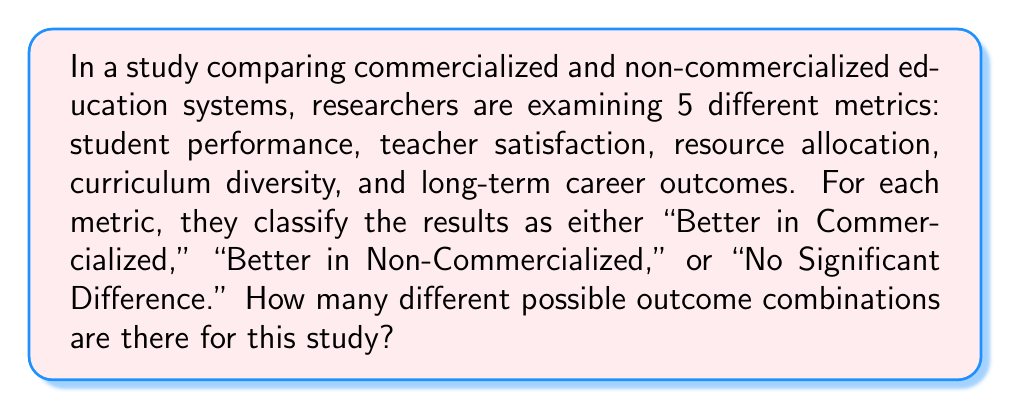Could you help me with this problem? Let's approach this step-by-step:

1) For each metric, there are 3 possible outcomes:
   - Better in Commercialized
   - Better in Non-Commercialized
   - No Significant Difference

2) We have 5 different metrics being examined.

3) This scenario represents a combination with repetition allowed, where:
   - We are selecting an outcome for each of the 5 metrics
   - The order matters (each metric is distinct)
   - We can "reuse" outcomes (e.g., multiple metrics can be "Better in Commercialized")

4) In combinatorics, this type of problem is solved using the multiplication principle.

5) For each metric, we have 3 choices, and we make this choice 5 times (once for each metric).

6) Therefore, the total number of possible outcome combinations is:

   $$ 3 \times 3 \times 3 \times 3 \times 3 = 3^5 $$

7) Calculating this:

   $$ 3^5 = 3 \times 3 \times 3 \times 3 \times 3 = 243 $$

Thus, there are 243 different possible outcome combinations for this study.
Answer: 243 